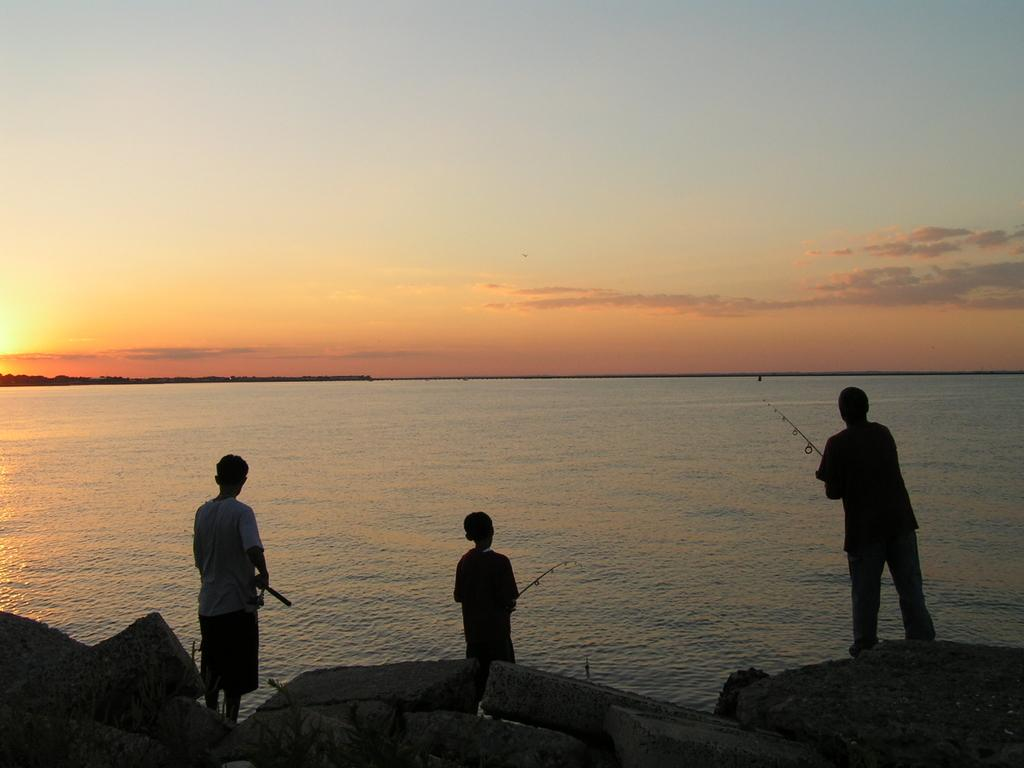How many people are in the image? There are three boys in the image. What are the boys doing in the image? The boys are fishing in the water. What can be seen at the top of the image? The sky is visible at the top of the image. What type of spoon can be seen in the image? There is no spoon present in the image. How many deer are visible in the image? There are no deer present in the image. 